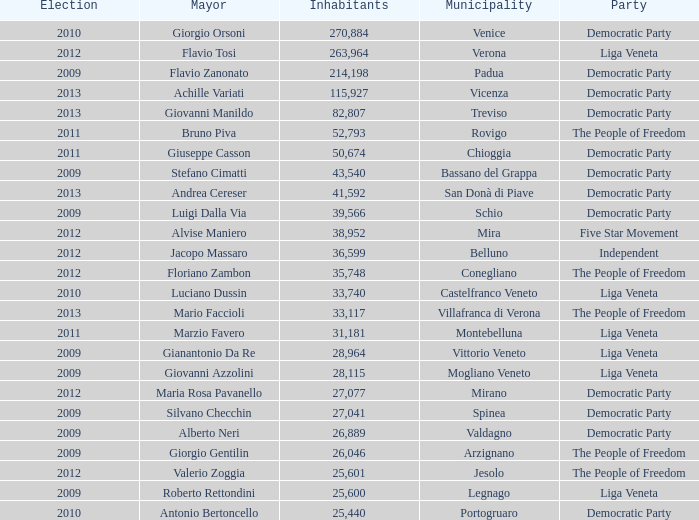In the election earlier than 2012 how many Inhabitants had a Party of five star movement? None. 